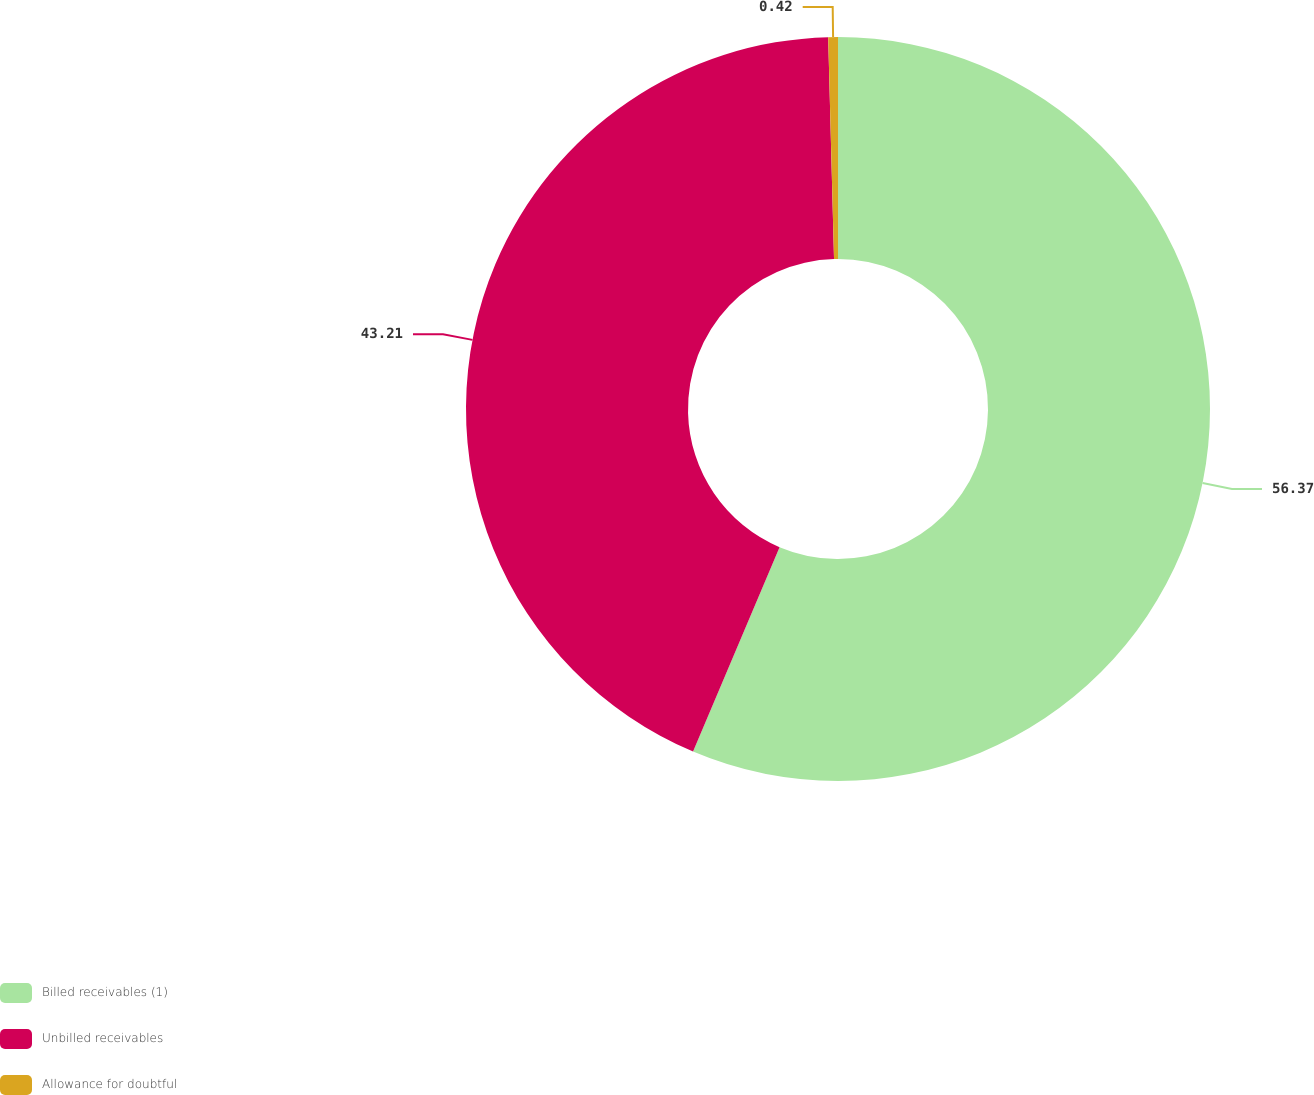Convert chart to OTSL. <chart><loc_0><loc_0><loc_500><loc_500><pie_chart><fcel>Billed receivables (1)<fcel>Unbilled receivables<fcel>Allowance for doubtful<nl><fcel>56.37%<fcel>43.21%<fcel>0.42%<nl></chart> 